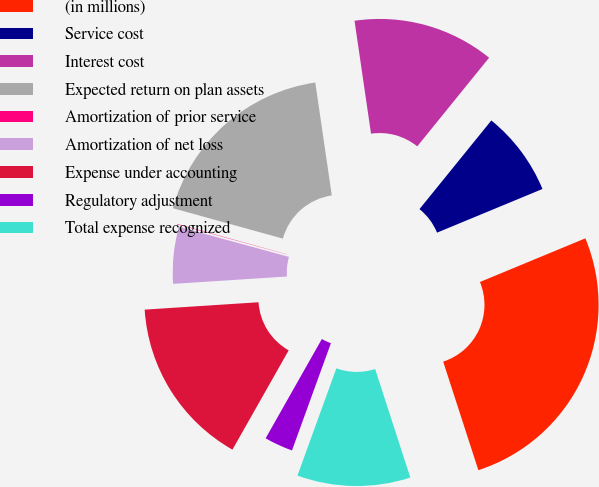Convert chart. <chart><loc_0><loc_0><loc_500><loc_500><pie_chart><fcel>(in millions)<fcel>Service cost<fcel>Interest cost<fcel>Expected return on plan assets<fcel>Amortization of prior service<fcel>Amortization of net loss<fcel>Expense under accounting<fcel>Regulatory adjustment<fcel>Total expense recognized<nl><fcel>26.26%<fcel>7.91%<fcel>13.15%<fcel>18.4%<fcel>0.04%<fcel>5.28%<fcel>15.77%<fcel>2.66%<fcel>10.53%<nl></chart> 